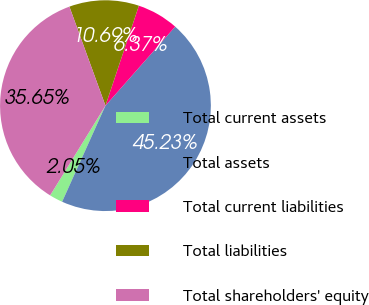<chart> <loc_0><loc_0><loc_500><loc_500><pie_chart><fcel>Total current assets<fcel>Total assets<fcel>Total current liabilities<fcel>Total liabilities<fcel>Total shareholders' equity<nl><fcel>2.05%<fcel>45.23%<fcel>6.37%<fcel>10.69%<fcel>35.65%<nl></chart> 